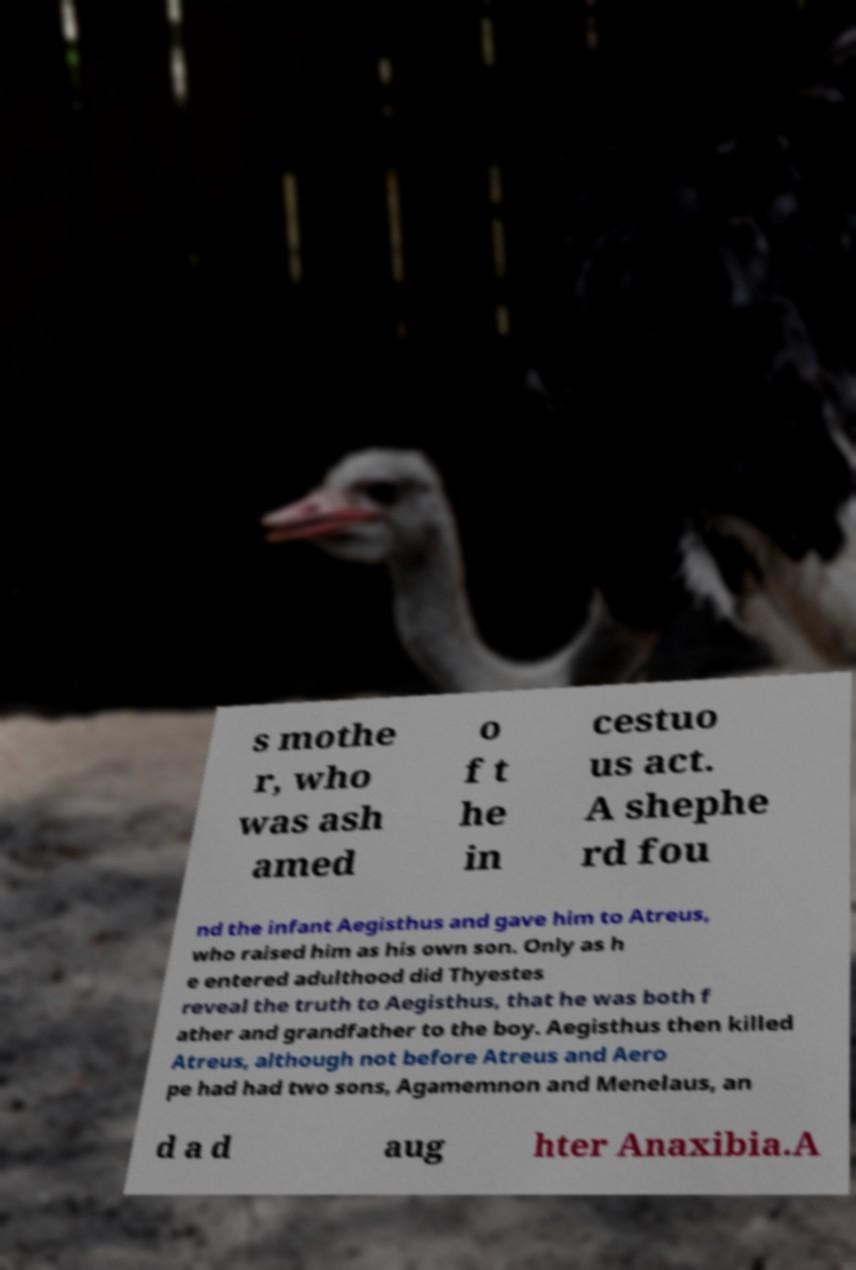Can you read and provide the text displayed in the image?This photo seems to have some interesting text. Can you extract and type it out for me? s mothe r, who was ash amed o f t he in cestuo us act. A shephe rd fou nd the infant Aegisthus and gave him to Atreus, who raised him as his own son. Only as h e entered adulthood did Thyestes reveal the truth to Aegisthus, that he was both f ather and grandfather to the boy. Aegisthus then killed Atreus, although not before Atreus and Aero pe had had two sons, Agamemnon and Menelaus, an d a d aug hter Anaxibia.A 